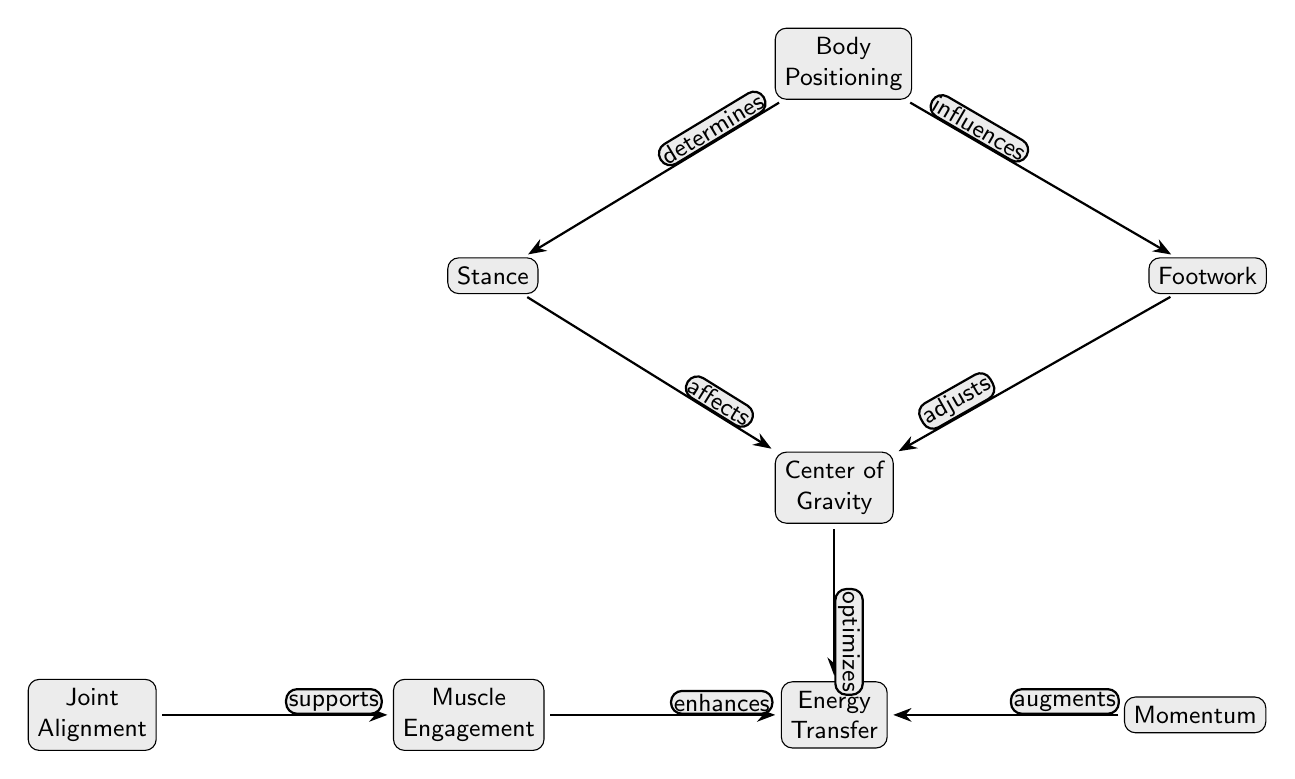What is the topmost node in the diagram? The diagram's structure shows that "Body Positioning" is the topmost node, as it is positioned at the highest point and directs connections downward.
Answer: Body Positioning How many nodes are in the diagram? By counting all the distinct elements presented as nodes in the diagram, there are a total of 8 nodes visible.
Answer: 8 What relationship does "Stance" have with "Center of Gravity"? The diagram indicates that "Stance" affects "Center of Gravity" as demonstrated by the directed edge; thus, the relationship is based on how "Stance" influences "Center of Gravity."
Answer: affects Which node is influenced by both "Body Positioning" and "Footwork"? The node "Center of Gravity" is influenced by "Body Positioning" and "Footwork," as both have directed edges pointing toward it, showing that they contribute to its concept.
Answer: Center of Gravity What enhances "Energy Transfer"? The node "Muscle Engagement" is shown to enhance "Energy Transfer" in the diagram, as indicated by the directed edge connecting it to "Energy Transfer."
Answer: Muscle Engagement How are "Joint Alignment" and "Muscle Engagement" related? The diagram indicates that "Joint Alignment" supports "Muscle Engagement." This relationship is depicted through the directed edge pointing from "Joint Alignment" to "Muscle Engagement."
Answer: supports What directly optimizes "Energy Transfer"? "Center of Gravity" directly optimizes "Energy Transfer," as illustrated by the directed edge leading from "Center of Gravity" to "Energy Transfer."
Answer: optimizes Which node augments "Energy Transfer"? According to the diagram, "Momentum" augments "Energy Transfer." This is clear from the directed edge that connects them in a positive relationship.
Answer: augments 